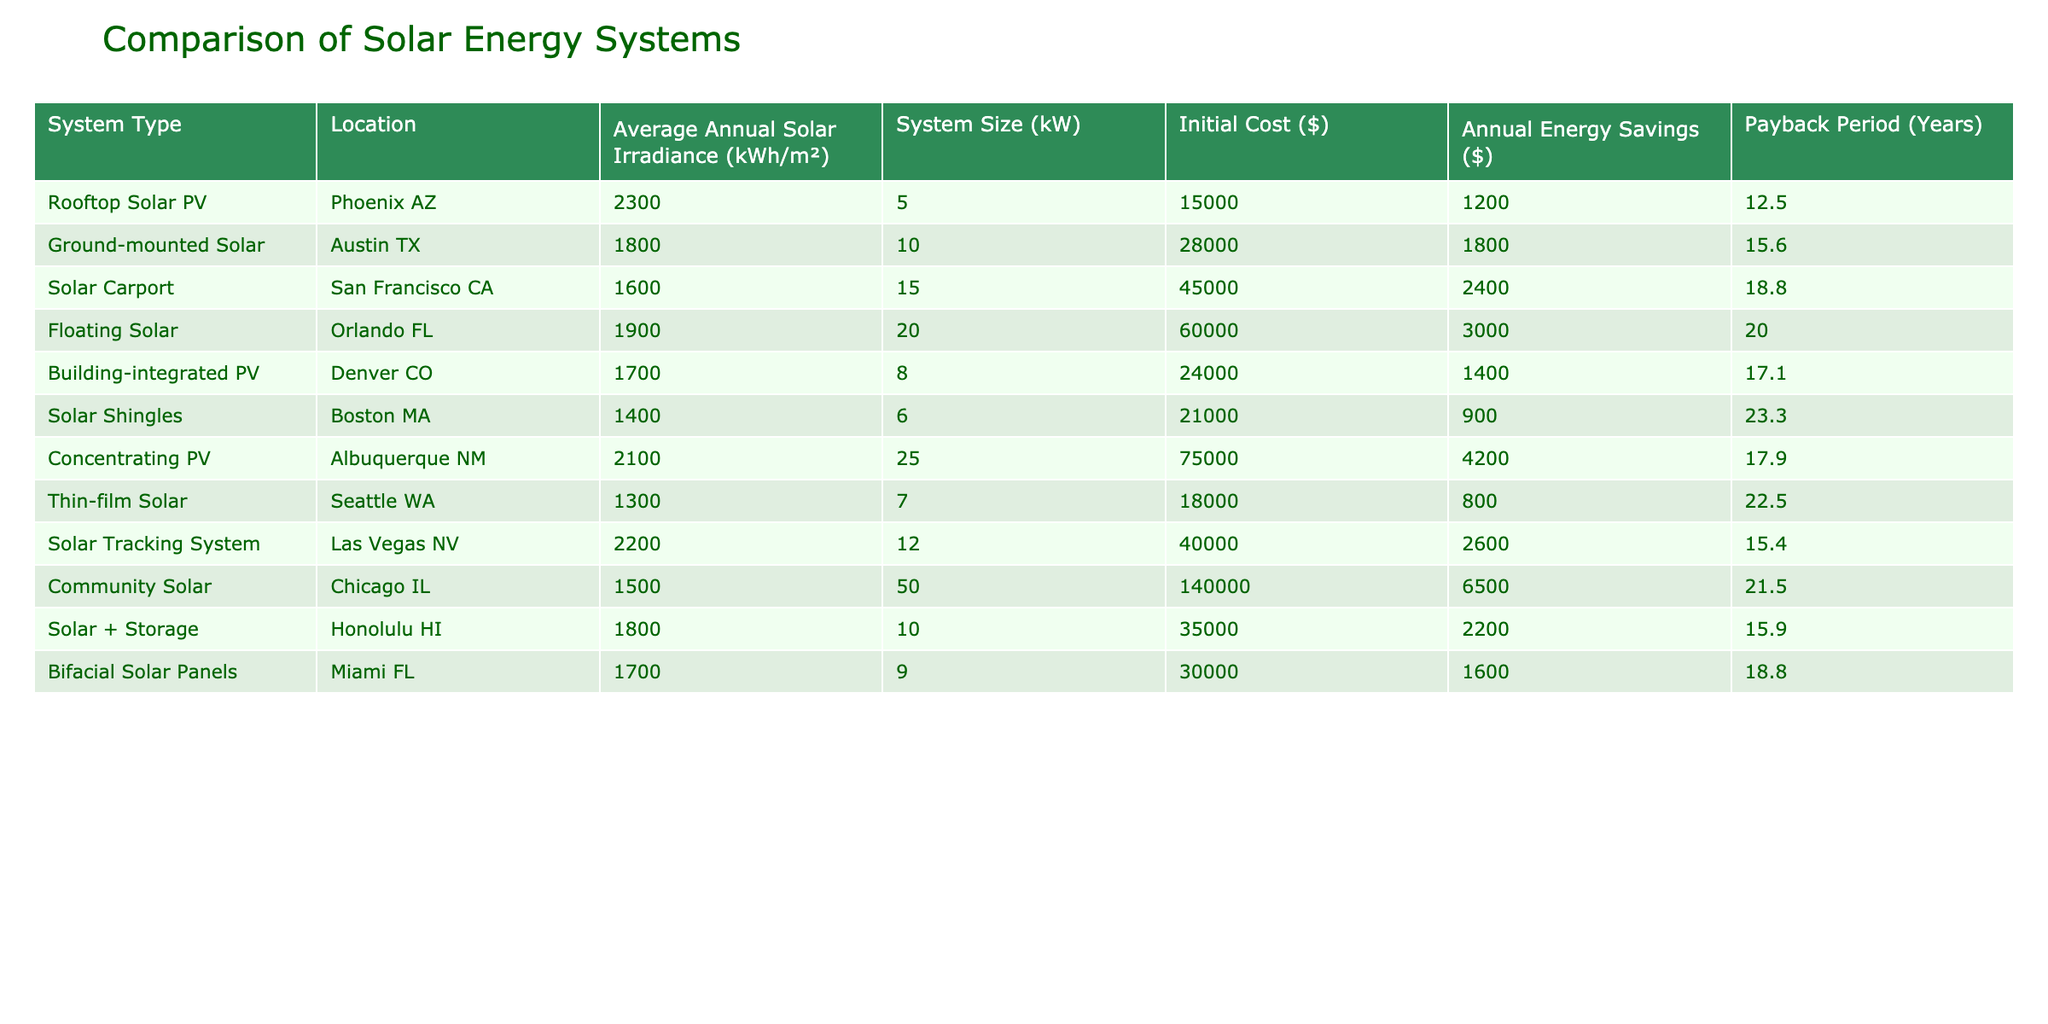What is the payback period for Rooftop Solar PV in Phoenix AZ? The payback period for Rooftop Solar PV is directly provided in the table under the corresponding location and system type, which is 12.5 years.
Answer: 12.5 years Which solar energy system has the longest payback period, and what is that period? By examining the payback periods for all systems listed, the system with the longest payback period is Solar Shingles in Boston MA, which has a period of 23.3 years.
Answer: Solar Shingles, 23.3 years How much is the payback period difference between Ground-mounted Solar in Austin TX and Bifacial Solar Panels in Miami FL? Ground-mounted Solar in Austin TX has a payback period of 15.6 years, and Bifacial Solar Panels in Miami FL has a payback period of 18.8 years. The difference is calculated as 18.8 - 15.6 = 3.2 years.
Answer: 3.2 years Is the payback period for Solar Carport in San Francisco CA greater than the payback period for Building-integrated PV in Denver CO? The payback period for Solar Carport is 18.8 years and for Building-integrated PV is 17.1 years. Since 18.8 is greater than 17.1, the answer is yes.
Answer: Yes What is the average payback period for all systems listed in the table? First, sum the payback periods: 12.5 + 15.6 + 18.8 + 20.0 + 17.1 + 23.3 + 17.9 + 22.5 + 15.4 + 21.5 + 15.9 + 18.8 =  242.0 years. Then divide this total by the number of systems (12): 242.0 / 12 = 20.17 years.
Answer: 20.17 years How many solar energy systems have a payback period of over 20 years? By checking each system's payback period in the table, Solar Carport (18.8), Floating Solar (20.0), Solar Shingles (23.3), and Community Solar (21.5) have payback periods over 20. Therefore, there are two systems with a payback period greater than 20 years: Solar Shingles and Community Solar.
Answer: 2 What is the total annual energy savings from all listed solar systems? The total annual energy savings can be calculated by summing the values under Annual Energy Savings: 1200 + 1800 + 2400 + 3000 + 1400 + 900 + 4200 + 800 + 2600 + 6500 + 2200 + 1600 = 25,100 dollars.
Answer: 25,100 dollars Are all systems listed have a payback period of less than 25 years? Evaluating each system's payback period, the longest is 23.3 years for Solar Shingles. Therefore, since no system exceeds 25 years, the answer is yes.
Answer: Yes 